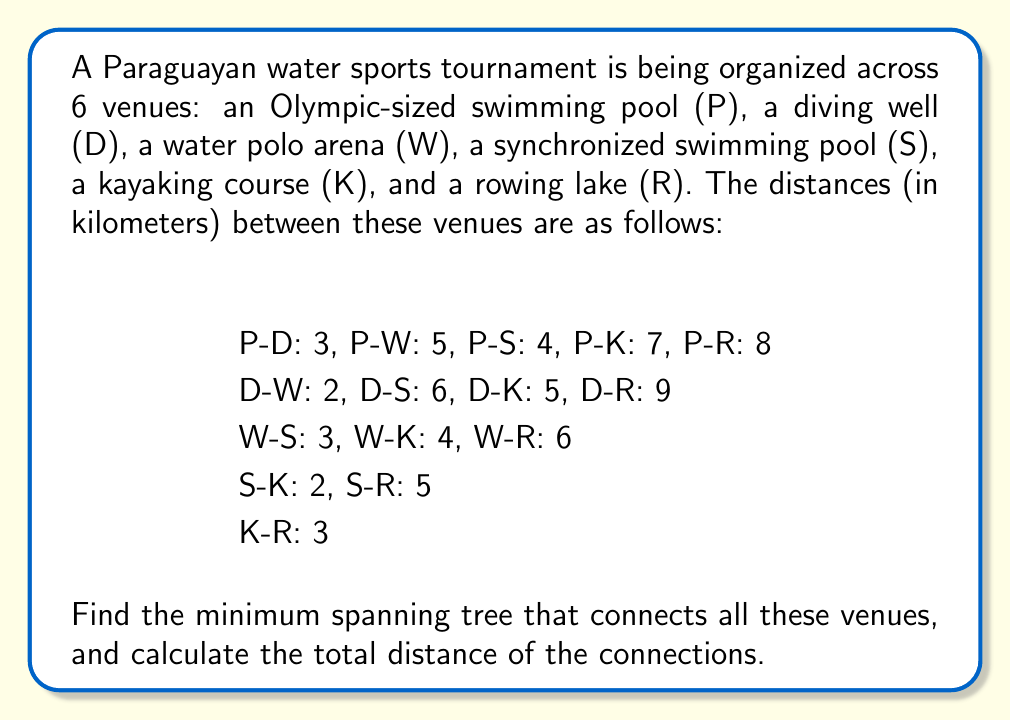Could you help me with this problem? To solve this problem, we'll use Kruskal's algorithm to find the minimum spanning tree (MST) of the graph representing the water sport venues.

Step 1: Sort all edges in ascending order of weight (distance):
1. D-W: 2
2. S-K: 2
3. P-D: 3
4. W-S: 3
5. K-R: 3
6. P-S: 4
7. W-K: 4
8. P-W: 5
9. D-K: 5
10. S-R: 5
11. W-R: 6
12. D-S: 6
13. P-K: 7
14. P-R: 8
15. D-R: 9

Step 2: Initialize a forest with each vertex in its own tree.

Step 3: Iterate through the sorted edges, adding each edge to the MST if it doesn't create a cycle:

1. Add D-W (2 km)
2. Add S-K (2 km)
3. Add P-D (3 km)
4. Add K-R (3 km)
5. Add W-S (3 km)

At this point, all vertices are connected, and we have our minimum spanning tree.

The resulting MST is:
P -- D -- W -- S -- K -- R

Step 4: Calculate the total distance by summing the weights of the edges in the MST:
Total distance = 2 + 2 + 3 + 3 + 3 = 13 km

Therefore, the minimum spanning tree connects all venues with a total distance of 13 kilometers.
Answer: The minimum spanning tree connecting all water sport venues is:
P -- D -- W -- S -- K -- R
with a total distance of 13 kilometers. 